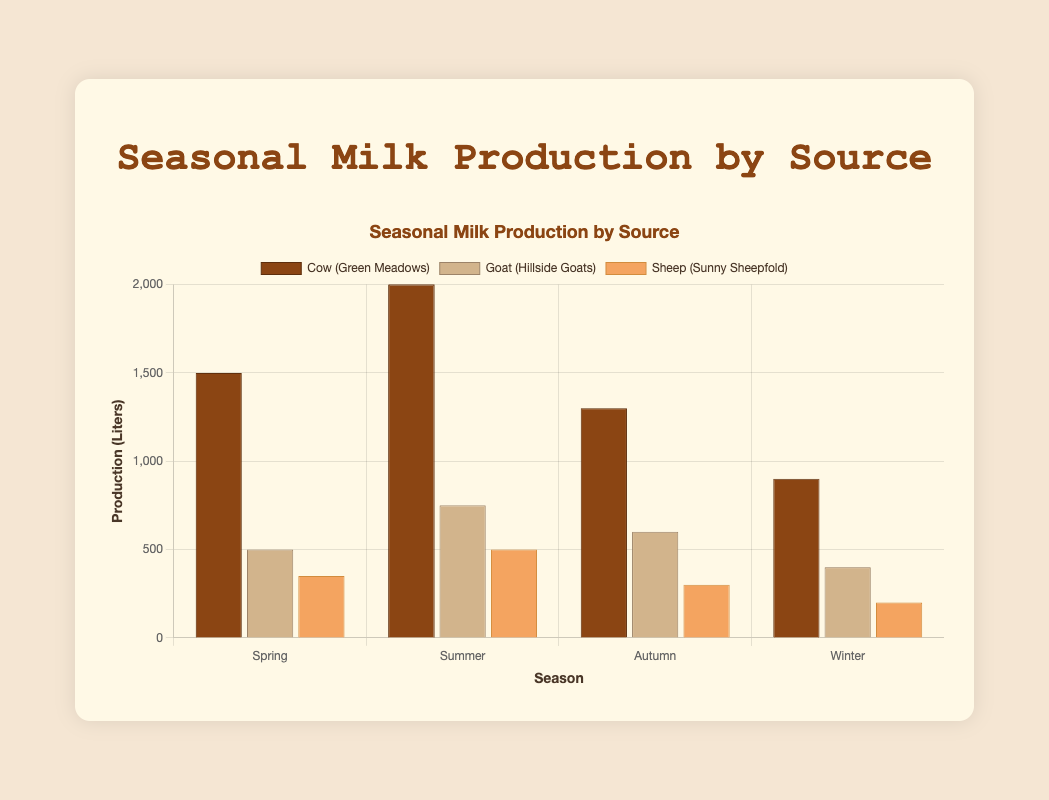Which season had the highest cow milk production? The "Summer" bar for cows appears tallest, suggesting that season had the highest cow milk production when compared to the other seasons.
Answer: Summer How much more milk did goats produce in Summer than in Winter? The goat milk production in Summer is 750 liters and in Winter is 400 liters. The difference is calculated as follows: 750 - 400 = 350 liters.
Answer: 350 liters What is the total milk production of sheep across all seasons? Summing the sheep milk production for all seasons: 350 (Spring) + 500 (Summer) + 300 (Autumn) + 200 (Winter) = 1350 liters.
Answer: 1350 liters Which milk source had the smallest production in any season, and in which season and source did it occur? By observing the heights of all the bars, the shortest bar is for sheep in Winter, indicating the smallest production which is for sheep in Winter.
Answer: Sheep in Winter Compare the milk production of cows and goats in Autumn. Which was higher, and by how much? The cow milk production in Autumn was 1300 liters, while goat milk production was 600 liters. The difference is calculated as follows: 1300 - 600 = 700 liters. Thus, cow milk production was higher by 700 liters.
Answer: Cow milk production was higher by 700 liters What are the colors used to represent Cow, Goat, and Sheep milk production in the grouped bar chart? The colors representing the milk sources are: Brown for Cow, Beige for Goat, and Sandy Brown for Sheep.
Answer: Brown for Cow, Beige for Goat, Sandy Brown for Sheep Under which season does the milk production for all sources (Cow, Goat, and Sheep) have the highest combined total? Summing the milk production for all sources for each season: 
- Spring: 1500 + 500 + 350 = 2350 liters 
- Summer: 2000 + 750 + 500 = 3250 liters 
- Autumn: 1300 + 600 + 300 = 2200 liters 
- Winter: 900 + 400 + 200 = 1500 liters 
The highest combined total is in Summer with 3250 liters.
Answer: Summer Which dairy farm produced the maximum amount of milk in any season, and what was the amount? The maximum production observed was by Green Meadows (Cow) in Summer, producing 2000 liters.
Answer: Green Meadows with 2000 liters in Summer What is the average milk production of sheep across all seasons? Summing sheep milk production across all seasons: 350 (Spring) + 500 (Summer) + 300 (Autumn) + 200 (Winter) = 1350 liters. Number of seasons is 4. The average is calculated as follows: 1350 / 4 = 337.5 liters.
Answer: 337.5 liters 